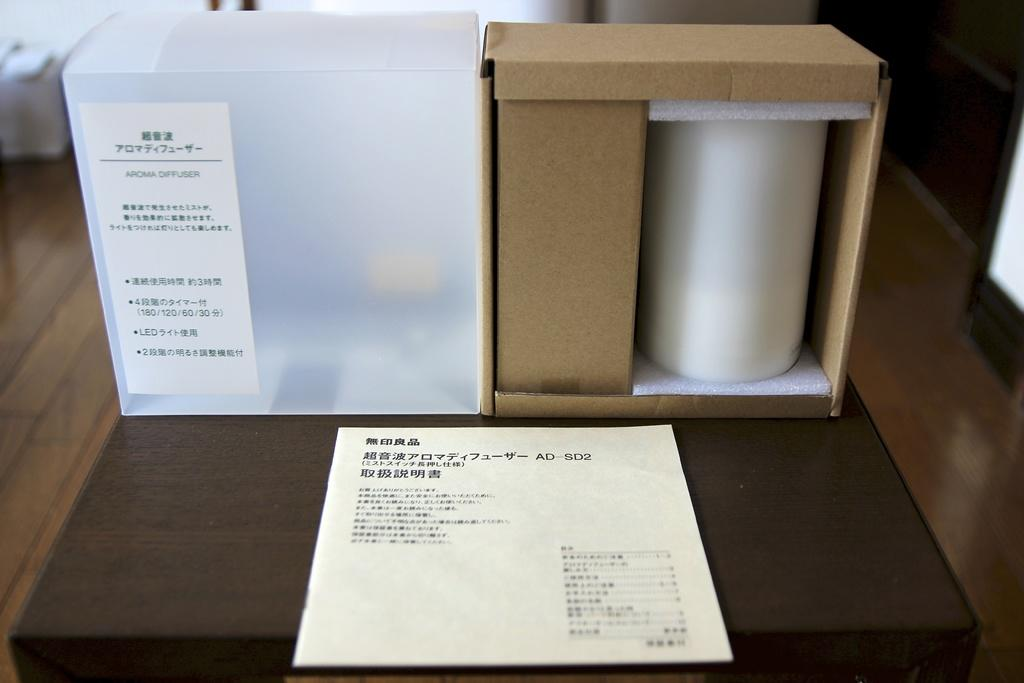What can be seen in the image? There are objects in the image. Can you describe one specific object in the image? There is a paper on a wooden surface in the image. Are there any fairies visible in the image? No, there are no fairies present in the image. What type of leaf can be seen on the wooden surface? There is no leaf visible on the wooden surface in the image. 